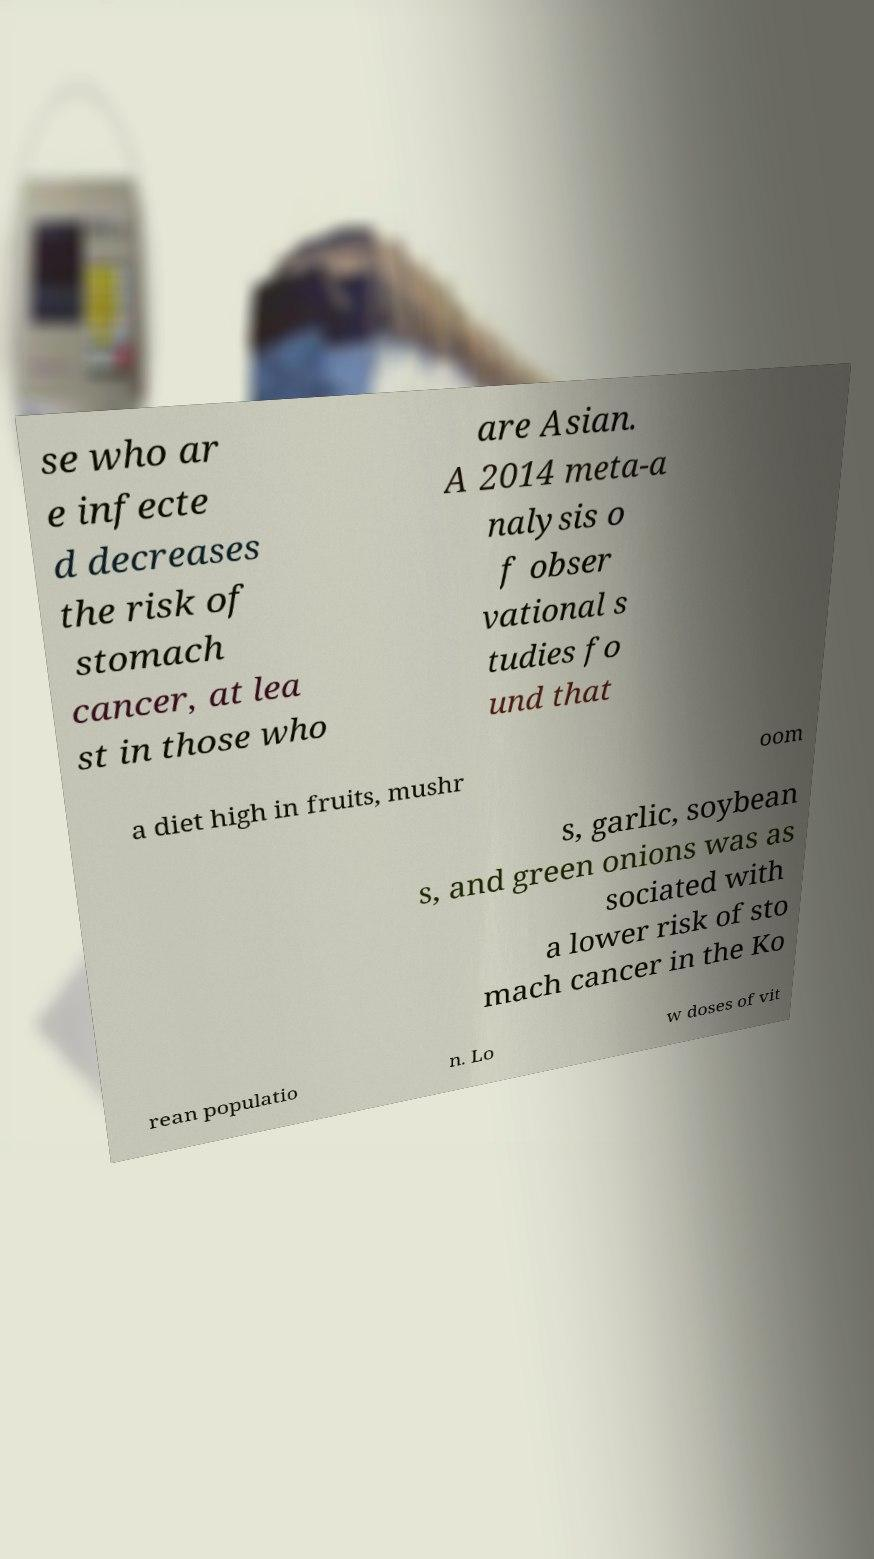What messages or text are displayed in this image? I need them in a readable, typed format. se who ar e infecte d decreases the risk of stomach cancer, at lea st in those who are Asian. A 2014 meta-a nalysis o f obser vational s tudies fo und that a diet high in fruits, mushr oom s, garlic, soybean s, and green onions was as sociated with a lower risk of sto mach cancer in the Ko rean populatio n. Lo w doses of vit 